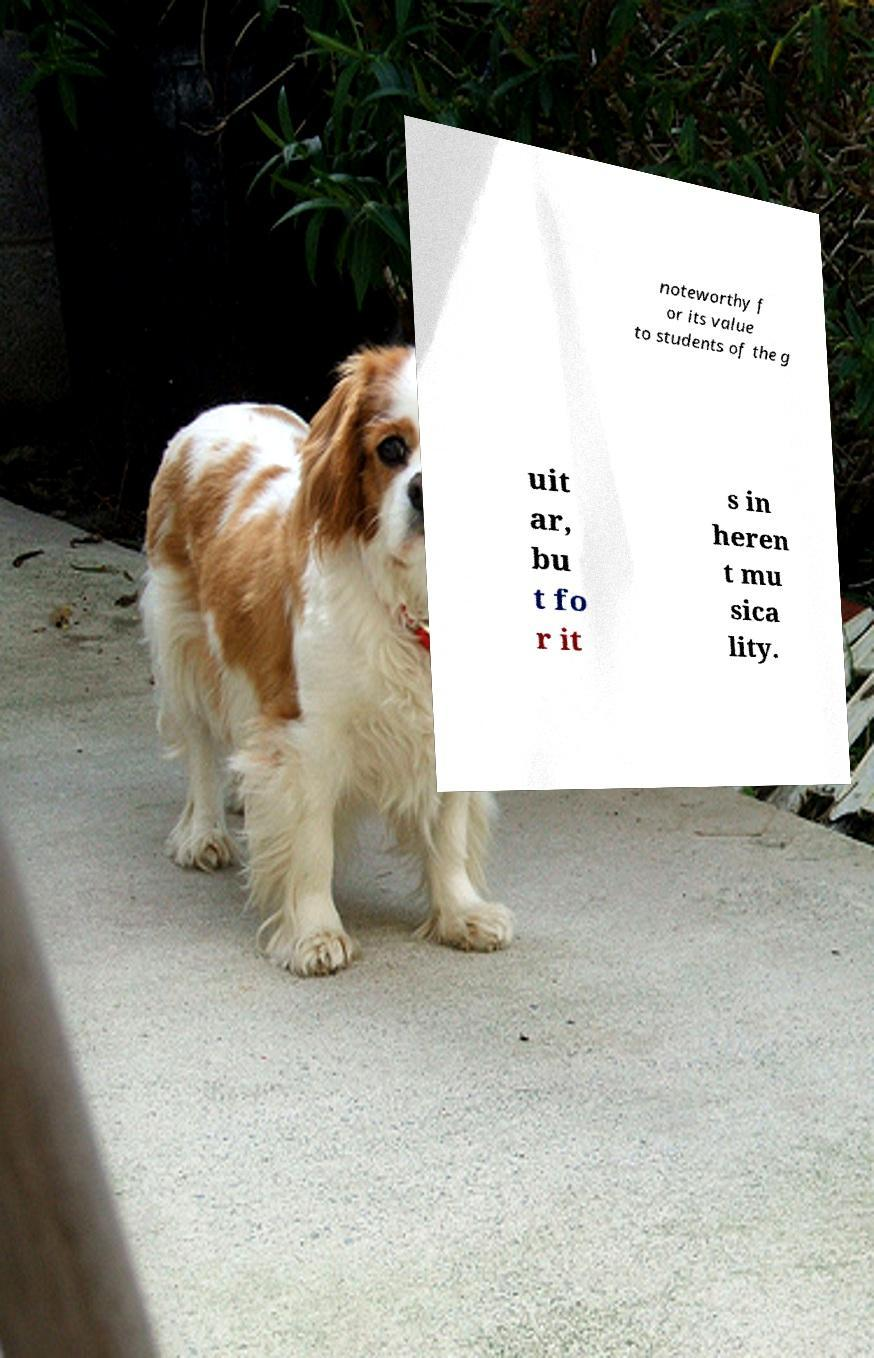Can you accurately transcribe the text from the provided image for me? noteworthy f or its value to students of the g uit ar, bu t fo r it s in heren t mu sica lity. 